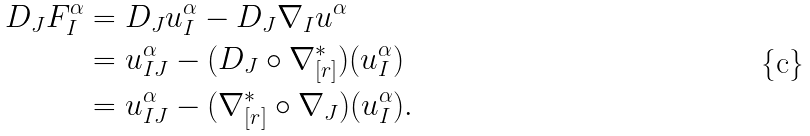<formula> <loc_0><loc_0><loc_500><loc_500>D _ { J } F _ { I } ^ { \alpha } & = D _ { J } u _ { I } ^ { \alpha } - D _ { J } \nabla _ { I } u ^ { \alpha } \\ & = u _ { I J } ^ { \alpha } - ( D _ { J } \circ \nabla _ { [ r ] } ^ { \ast } ) ( u _ { I } ^ { \alpha } ) \\ & = u _ { I J } ^ { \alpha } - ( \nabla _ { [ r ] } ^ { \ast } \circ \nabla _ { J } ) ( u _ { I } ^ { \alpha } ) .</formula> 